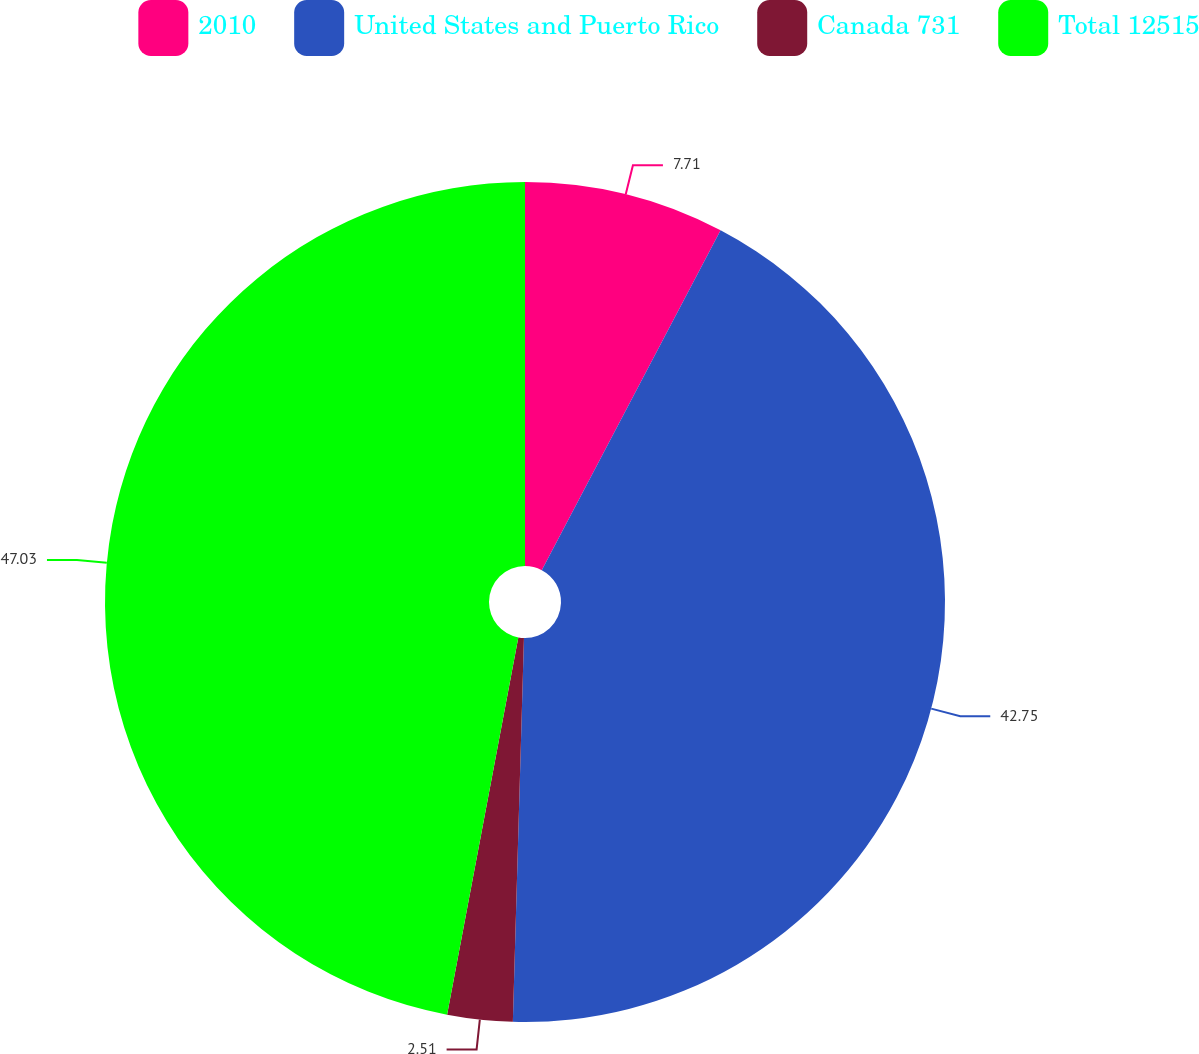<chart> <loc_0><loc_0><loc_500><loc_500><pie_chart><fcel>2010<fcel>United States and Puerto Rico<fcel>Canada 731<fcel>Total 12515<nl><fcel>7.71%<fcel>42.75%<fcel>2.51%<fcel>47.03%<nl></chart> 